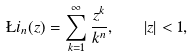Convert formula to latex. <formula><loc_0><loc_0><loc_500><loc_500>\L i _ { n } ( z ) = \sum _ { k = 1 } ^ { \infty } \frac { z ^ { k } } { k ^ { n } } , \quad | z | < 1 ,</formula> 